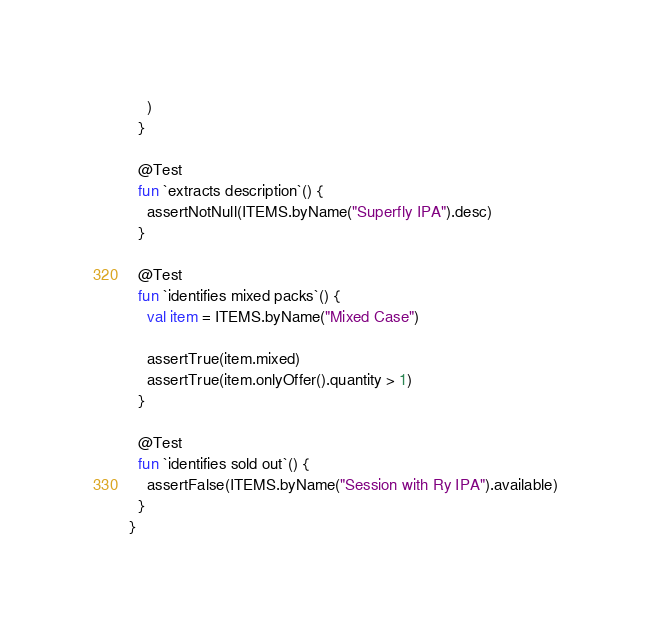Convert code to text. <code><loc_0><loc_0><loc_500><loc_500><_Kotlin_>    )
  }

  @Test
  fun `extracts description`() {
    assertNotNull(ITEMS.byName("Superfly IPA").desc)
  }

  @Test
  fun `identifies mixed packs`() {
    val item = ITEMS.byName("Mixed Case")

    assertTrue(item.mixed)
    assertTrue(item.onlyOffer().quantity > 1)
  }

  @Test
  fun `identifies sold out`() {
    assertFalse(ITEMS.byName("Session with Ry IPA").available)
  }
}

</code> 